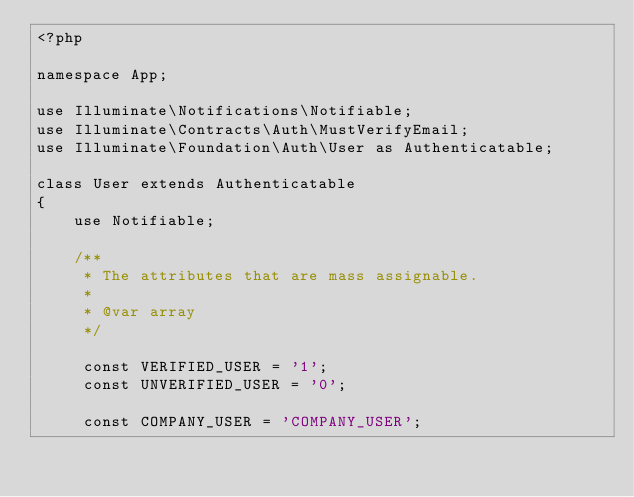<code> <loc_0><loc_0><loc_500><loc_500><_PHP_><?php

namespace App;

use Illuminate\Notifications\Notifiable;
use Illuminate\Contracts\Auth\MustVerifyEmail;
use Illuminate\Foundation\Auth\User as Authenticatable;

class User extends Authenticatable
{
    use Notifiable;

    /**
     * The attributes that are mass assignable.
     *
     * @var array
     */

     const VERIFIED_USER = '1';
     const UNVERIFIED_USER = '0';

     const COMPANY_USER = 'COMPANY_USER';</code> 